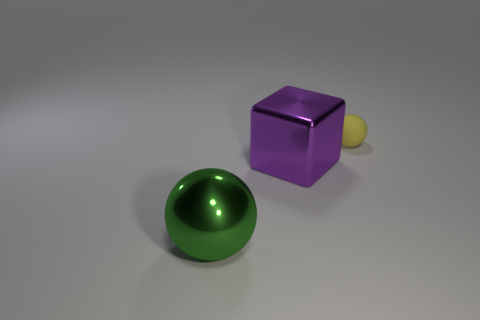How many big objects are either metallic objects or blocks?
Your answer should be compact. 2. Are there the same number of purple metallic things on the left side of the green sphere and spheres?
Give a very brief answer. No. Are there any small yellow things behind the large metal cube?
Give a very brief answer. Yes. What number of rubber things are either small yellow objects or tiny purple objects?
Your response must be concise. 1. What number of balls are on the right side of the large purple metallic cube?
Ensure brevity in your answer.  1. Is there a blue object that has the same size as the block?
Ensure brevity in your answer.  No. Are there any cubes of the same color as the tiny rubber object?
Give a very brief answer. No. Are there any other things that have the same size as the yellow matte ball?
Your answer should be compact. No. How many other cubes have the same color as the shiny block?
Your response must be concise. 0. Do the small sphere and the ball in front of the tiny yellow object have the same color?
Your answer should be very brief. No. 